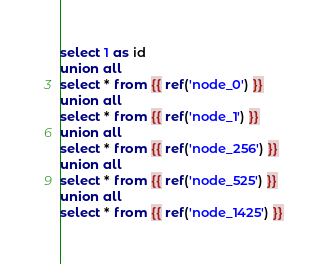<code> <loc_0><loc_0><loc_500><loc_500><_SQL_>select 1 as id
union all
select * from {{ ref('node_0') }}
union all
select * from {{ ref('node_1') }}
union all
select * from {{ ref('node_256') }}
union all
select * from {{ ref('node_525') }}
union all
select * from {{ ref('node_1425') }}</code> 